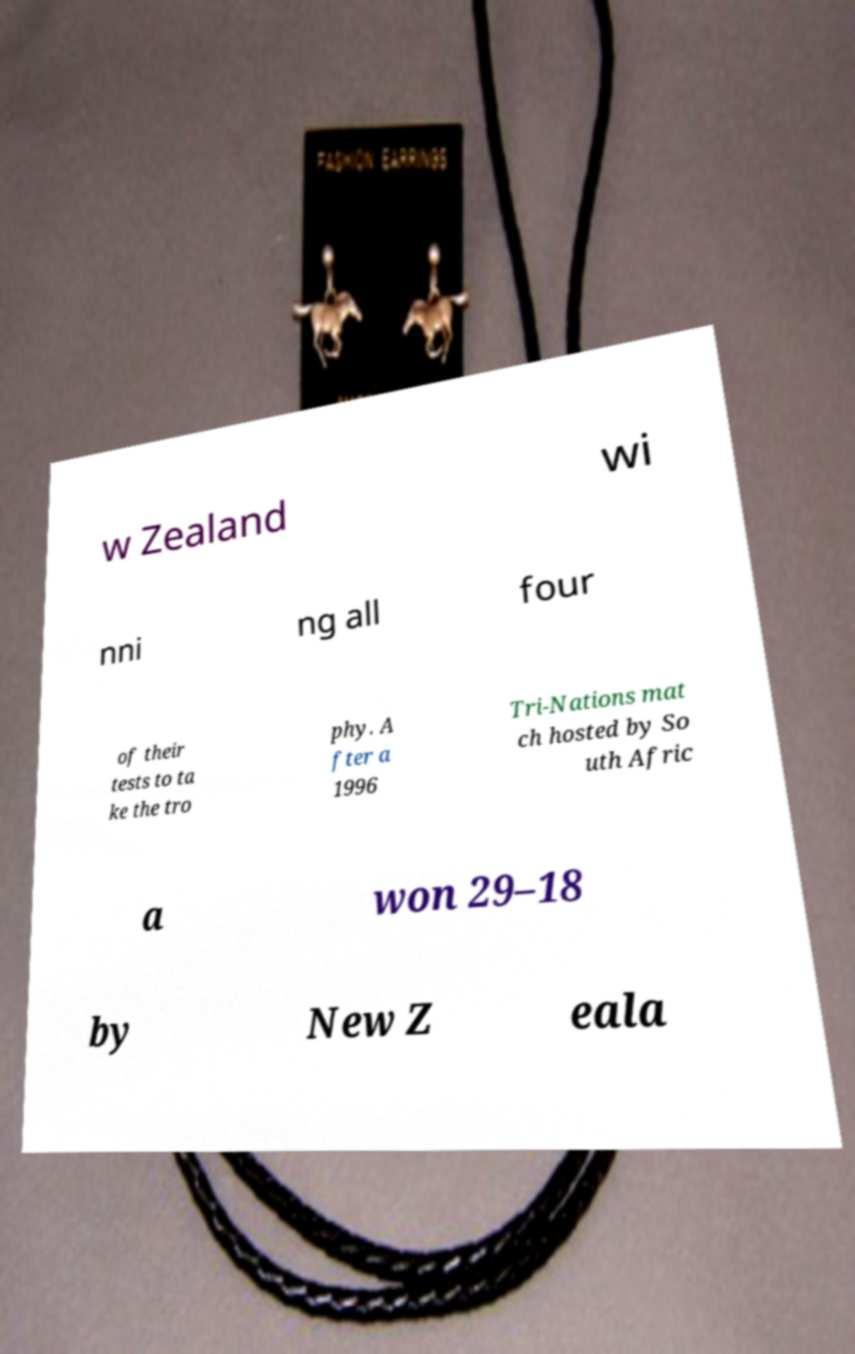Can you read and provide the text displayed in the image?This photo seems to have some interesting text. Can you extract and type it out for me? w Zealand wi nni ng all four of their tests to ta ke the tro phy. A fter a 1996 Tri-Nations mat ch hosted by So uth Afric a won 29–18 by New Z eala 